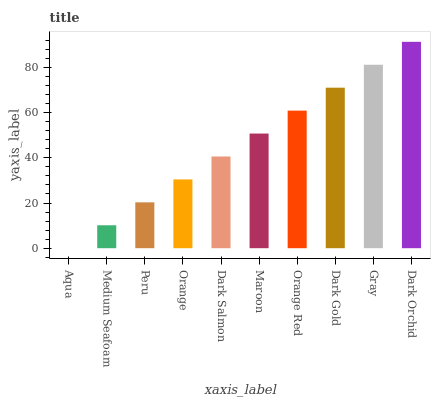Is Aqua the minimum?
Answer yes or no. Yes. Is Dark Orchid the maximum?
Answer yes or no. Yes. Is Medium Seafoam the minimum?
Answer yes or no. No. Is Medium Seafoam the maximum?
Answer yes or no. No. Is Medium Seafoam greater than Aqua?
Answer yes or no. Yes. Is Aqua less than Medium Seafoam?
Answer yes or no. Yes. Is Aqua greater than Medium Seafoam?
Answer yes or no. No. Is Medium Seafoam less than Aqua?
Answer yes or no. No. Is Maroon the high median?
Answer yes or no. Yes. Is Dark Salmon the low median?
Answer yes or no. Yes. Is Peru the high median?
Answer yes or no. No. Is Orange Red the low median?
Answer yes or no. No. 